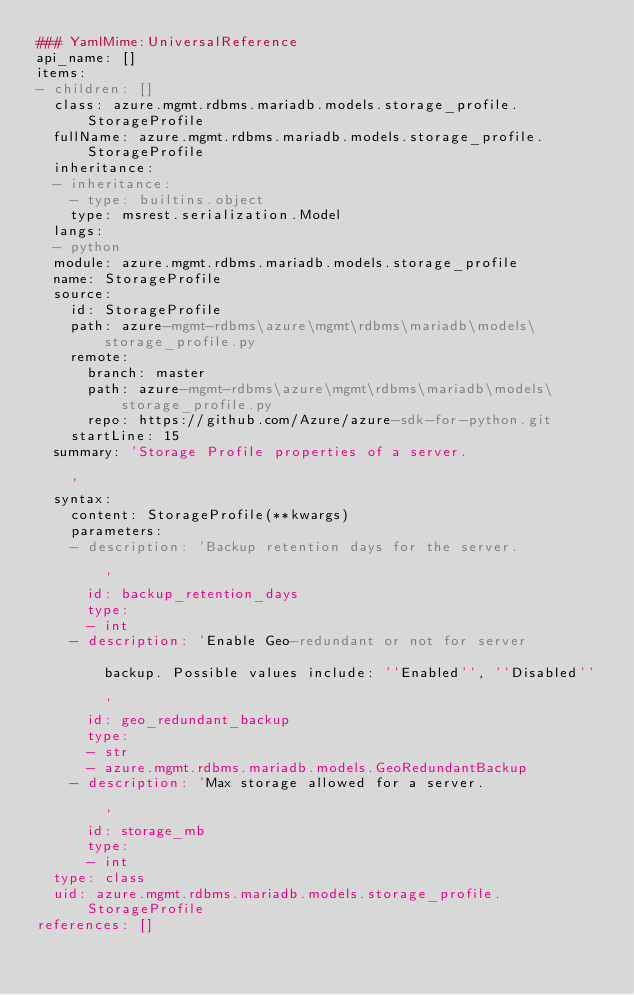Convert code to text. <code><loc_0><loc_0><loc_500><loc_500><_YAML_>### YamlMime:UniversalReference
api_name: []
items:
- children: []
  class: azure.mgmt.rdbms.mariadb.models.storage_profile.StorageProfile
  fullName: azure.mgmt.rdbms.mariadb.models.storage_profile.StorageProfile
  inheritance:
  - inheritance:
    - type: builtins.object
    type: msrest.serialization.Model
  langs:
  - python
  module: azure.mgmt.rdbms.mariadb.models.storage_profile
  name: StorageProfile
  source:
    id: StorageProfile
    path: azure-mgmt-rdbms\azure\mgmt\rdbms\mariadb\models\storage_profile.py
    remote:
      branch: master
      path: azure-mgmt-rdbms\azure\mgmt\rdbms\mariadb\models\storage_profile.py
      repo: https://github.com/Azure/azure-sdk-for-python.git
    startLine: 15
  summary: 'Storage Profile properties of a server.

    '
  syntax:
    content: StorageProfile(**kwargs)
    parameters:
    - description: 'Backup retention days for the server.

        '
      id: backup_retention_days
      type:
      - int
    - description: 'Enable Geo-redundant or not for server

        backup. Possible values include: ''Enabled'', ''Disabled''

        '
      id: geo_redundant_backup
      type:
      - str
      - azure.mgmt.rdbms.mariadb.models.GeoRedundantBackup
    - description: 'Max storage allowed for a server.

        '
      id: storage_mb
      type:
      - int
  type: class
  uid: azure.mgmt.rdbms.mariadb.models.storage_profile.StorageProfile
references: []
</code> 